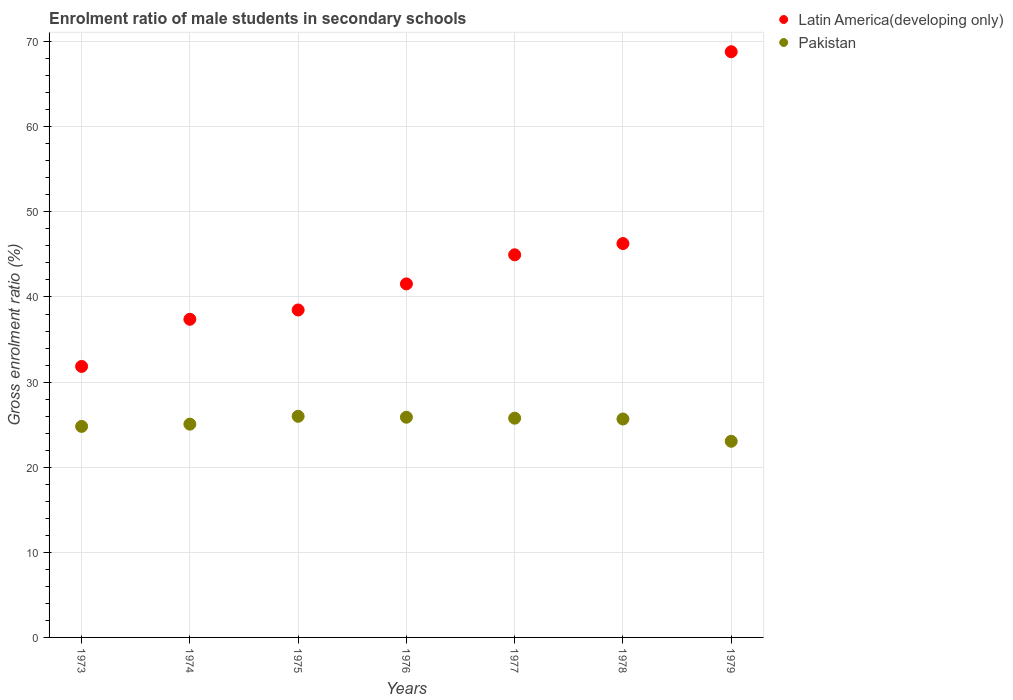How many different coloured dotlines are there?
Provide a succinct answer. 2. What is the enrolment ratio of male students in secondary schools in Pakistan in 1979?
Give a very brief answer. 23.05. Across all years, what is the maximum enrolment ratio of male students in secondary schools in Pakistan?
Provide a short and direct response. 25.98. Across all years, what is the minimum enrolment ratio of male students in secondary schools in Pakistan?
Offer a terse response. 23.05. In which year was the enrolment ratio of male students in secondary schools in Pakistan maximum?
Make the answer very short. 1975. In which year was the enrolment ratio of male students in secondary schools in Pakistan minimum?
Offer a very short reply. 1979. What is the total enrolment ratio of male students in secondary schools in Pakistan in the graph?
Give a very brief answer. 176.18. What is the difference between the enrolment ratio of male students in secondary schools in Pakistan in 1973 and that in 1977?
Provide a short and direct response. -0.97. What is the difference between the enrolment ratio of male students in secondary schools in Latin America(developing only) in 1973 and the enrolment ratio of male students in secondary schools in Pakistan in 1974?
Your response must be concise. 6.78. What is the average enrolment ratio of male students in secondary schools in Pakistan per year?
Offer a very short reply. 25.17. In the year 1974, what is the difference between the enrolment ratio of male students in secondary schools in Latin America(developing only) and enrolment ratio of male students in secondary schools in Pakistan?
Your response must be concise. 12.32. In how many years, is the enrolment ratio of male students in secondary schools in Latin America(developing only) greater than 22 %?
Give a very brief answer. 7. What is the ratio of the enrolment ratio of male students in secondary schools in Pakistan in 1975 to that in 1978?
Offer a very short reply. 1.01. Is the enrolment ratio of male students in secondary schools in Pakistan in 1977 less than that in 1979?
Offer a terse response. No. What is the difference between the highest and the second highest enrolment ratio of male students in secondary schools in Pakistan?
Your response must be concise. 0.11. What is the difference between the highest and the lowest enrolment ratio of male students in secondary schools in Pakistan?
Ensure brevity in your answer.  2.93. In how many years, is the enrolment ratio of male students in secondary schools in Latin America(developing only) greater than the average enrolment ratio of male students in secondary schools in Latin America(developing only) taken over all years?
Offer a very short reply. 3. Is the sum of the enrolment ratio of male students in secondary schools in Latin America(developing only) in 1978 and 1979 greater than the maximum enrolment ratio of male students in secondary schools in Pakistan across all years?
Offer a terse response. Yes. Does the enrolment ratio of male students in secondary schools in Latin America(developing only) monotonically increase over the years?
Provide a succinct answer. Yes. Is the enrolment ratio of male students in secondary schools in Latin America(developing only) strictly less than the enrolment ratio of male students in secondary schools in Pakistan over the years?
Make the answer very short. No. How many years are there in the graph?
Provide a succinct answer. 7. What is the difference between two consecutive major ticks on the Y-axis?
Keep it short and to the point. 10. Are the values on the major ticks of Y-axis written in scientific E-notation?
Offer a very short reply. No. Does the graph contain grids?
Provide a short and direct response. Yes. How many legend labels are there?
Offer a very short reply. 2. What is the title of the graph?
Make the answer very short. Enrolment ratio of male students in secondary schools. Does "Papua New Guinea" appear as one of the legend labels in the graph?
Provide a short and direct response. No. What is the label or title of the Y-axis?
Provide a short and direct response. Gross enrolment ratio (%). What is the Gross enrolment ratio (%) in Latin America(developing only) in 1973?
Provide a succinct answer. 31.84. What is the Gross enrolment ratio (%) in Pakistan in 1973?
Ensure brevity in your answer.  24.79. What is the Gross enrolment ratio (%) of Latin America(developing only) in 1974?
Offer a terse response. 37.38. What is the Gross enrolment ratio (%) of Pakistan in 1974?
Keep it short and to the point. 25.06. What is the Gross enrolment ratio (%) in Latin America(developing only) in 1975?
Your answer should be compact. 38.48. What is the Gross enrolment ratio (%) of Pakistan in 1975?
Ensure brevity in your answer.  25.98. What is the Gross enrolment ratio (%) of Latin America(developing only) in 1976?
Make the answer very short. 41.54. What is the Gross enrolment ratio (%) in Pakistan in 1976?
Your answer should be very brief. 25.87. What is the Gross enrolment ratio (%) of Latin America(developing only) in 1977?
Make the answer very short. 44.96. What is the Gross enrolment ratio (%) in Pakistan in 1977?
Offer a very short reply. 25.76. What is the Gross enrolment ratio (%) of Latin America(developing only) in 1978?
Your answer should be compact. 46.28. What is the Gross enrolment ratio (%) of Pakistan in 1978?
Your answer should be very brief. 25.66. What is the Gross enrolment ratio (%) in Latin America(developing only) in 1979?
Give a very brief answer. 68.82. What is the Gross enrolment ratio (%) in Pakistan in 1979?
Make the answer very short. 23.05. Across all years, what is the maximum Gross enrolment ratio (%) in Latin America(developing only)?
Your answer should be very brief. 68.82. Across all years, what is the maximum Gross enrolment ratio (%) in Pakistan?
Keep it short and to the point. 25.98. Across all years, what is the minimum Gross enrolment ratio (%) of Latin America(developing only)?
Offer a very short reply. 31.84. Across all years, what is the minimum Gross enrolment ratio (%) of Pakistan?
Make the answer very short. 23.05. What is the total Gross enrolment ratio (%) in Latin America(developing only) in the graph?
Provide a succinct answer. 309.3. What is the total Gross enrolment ratio (%) of Pakistan in the graph?
Give a very brief answer. 176.18. What is the difference between the Gross enrolment ratio (%) of Latin America(developing only) in 1973 and that in 1974?
Provide a short and direct response. -5.54. What is the difference between the Gross enrolment ratio (%) of Pakistan in 1973 and that in 1974?
Provide a short and direct response. -0.27. What is the difference between the Gross enrolment ratio (%) in Latin America(developing only) in 1973 and that in 1975?
Provide a short and direct response. -6.63. What is the difference between the Gross enrolment ratio (%) of Pakistan in 1973 and that in 1975?
Make the answer very short. -1.19. What is the difference between the Gross enrolment ratio (%) in Latin America(developing only) in 1973 and that in 1976?
Make the answer very short. -9.7. What is the difference between the Gross enrolment ratio (%) in Pakistan in 1973 and that in 1976?
Offer a very short reply. -1.08. What is the difference between the Gross enrolment ratio (%) of Latin America(developing only) in 1973 and that in 1977?
Your answer should be very brief. -13.12. What is the difference between the Gross enrolment ratio (%) in Pakistan in 1973 and that in 1977?
Make the answer very short. -0.97. What is the difference between the Gross enrolment ratio (%) in Latin America(developing only) in 1973 and that in 1978?
Ensure brevity in your answer.  -14.44. What is the difference between the Gross enrolment ratio (%) in Pakistan in 1973 and that in 1978?
Give a very brief answer. -0.87. What is the difference between the Gross enrolment ratio (%) in Latin America(developing only) in 1973 and that in 1979?
Make the answer very short. -36.98. What is the difference between the Gross enrolment ratio (%) in Pakistan in 1973 and that in 1979?
Provide a succinct answer. 1.75. What is the difference between the Gross enrolment ratio (%) of Latin America(developing only) in 1974 and that in 1975?
Offer a very short reply. -1.09. What is the difference between the Gross enrolment ratio (%) of Pakistan in 1974 and that in 1975?
Give a very brief answer. -0.92. What is the difference between the Gross enrolment ratio (%) of Latin America(developing only) in 1974 and that in 1976?
Make the answer very short. -4.16. What is the difference between the Gross enrolment ratio (%) in Pakistan in 1974 and that in 1976?
Your answer should be compact. -0.81. What is the difference between the Gross enrolment ratio (%) of Latin America(developing only) in 1974 and that in 1977?
Keep it short and to the point. -7.58. What is the difference between the Gross enrolment ratio (%) in Pakistan in 1974 and that in 1977?
Your answer should be very brief. -0.7. What is the difference between the Gross enrolment ratio (%) in Latin America(developing only) in 1974 and that in 1978?
Provide a short and direct response. -8.9. What is the difference between the Gross enrolment ratio (%) in Pakistan in 1974 and that in 1978?
Ensure brevity in your answer.  -0.6. What is the difference between the Gross enrolment ratio (%) in Latin America(developing only) in 1974 and that in 1979?
Your answer should be very brief. -31.44. What is the difference between the Gross enrolment ratio (%) in Pakistan in 1974 and that in 1979?
Your answer should be very brief. 2.01. What is the difference between the Gross enrolment ratio (%) in Latin America(developing only) in 1975 and that in 1976?
Provide a short and direct response. -3.06. What is the difference between the Gross enrolment ratio (%) of Pakistan in 1975 and that in 1976?
Offer a very short reply. 0.11. What is the difference between the Gross enrolment ratio (%) in Latin America(developing only) in 1975 and that in 1977?
Provide a short and direct response. -6.48. What is the difference between the Gross enrolment ratio (%) in Pakistan in 1975 and that in 1977?
Your response must be concise. 0.22. What is the difference between the Gross enrolment ratio (%) in Latin America(developing only) in 1975 and that in 1978?
Provide a short and direct response. -7.8. What is the difference between the Gross enrolment ratio (%) in Pakistan in 1975 and that in 1978?
Your answer should be very brief. 0.32. What is the difference between the Gross enrolment ratio (%) in Latin America(developing only) in 1975 and that in 1979?
Offer a terse response. -30.34. What is the difference between the Gross enrolment ratio (%) in Pakistan in 1975 and that in 1979?
Offer a terse response. 2.93. What is the difference between the Gross enrolment ratio (%) in Latin America(developing only) in 1976 and that in 1977?
Offer a terse response. -3.42. What is the difference between the Gross enrolment ratio (%) in Pakistan in 1976 and that in 1977?
Give a very brief answer. 0.11. What is the difference between the Gross enrolment ratio (%) of Latin America(developing only) in 1976 and that in 1978?
Provide a short and direct response. -4.74. What is the difference between the Gross enrolment ratio (%) of Pakistan in 1976 and that in 1978?
Your answer should be compact. 0.21. What is the difference between the Gross enrolment ratio (%) in Latin America(developing only) in 1976 and that in 1979?
Keep it short and to the point. -27.28. What is the difference between the Gross enrolment ratio (%) of Pakistan in 1976 and that in 1979?
Offer a terse response. 2.83. What is the difference between the Gross enrolment ratio (%) of Latin America(developing only) in 1977 and that in 1978?
Provide a short and direct response. -1.32. What is the difference between the Gross enrolment ratio (%) of Pakistan in 1977 and that in 1978?
Provide a short and direct response. 0.1. What is the difference between the Gross enrolment ratio (%) of Latin America(developing only) in 1977 and that in 1979?
Ensure brevity in your answer.  -23.86. What is the difference between the Gross enrolment ratio (%) in Pakistan in 1977 and that in 1979?
Your answer should be compact. 2.71. What is the difference between the Gross enrolment ratio (%) of Latin America(developing only) in 1978 and that in 1979?
Ensure brevity in your answer.  -22.54. What is the difference between the Gross enrolment ratio (%) in Pakistan in 1978 and that in 1979?
Give a very brief answer. 2.62. What is the difference between the Gross enrolment ratio (%) of Latin America(developing only) in 1973 and the Gross enrolment ratio (%) of Pakistan in 1974?
Offer a very short reply. 6.78. What is the difference between the Gross enrolment ratio (%) of Latin America(developing only) in 1973 and the Gross enrolment ratio (%) of Pakistan in 1975?
Give a very brief answer. 5.86. What is the difference between the Gross enrolment ratio (%) in Latin America(developing only) in 1973 and the Gross enrolment ratio (%) in Pakistan in 1976?
Give a very brief answer. 5.97. What is the difference between the Gross enrolment ratio (%) in Latin America(developing only) in 1973 and the Gross enrolment ratio (%) in Pakistan in 1977?
Your response must be concise. 6.08. What is the difference between the Gross enrolment ratio (%) in Latin America(developing only) in 1973 and the Gross enrolment ratio (%) in Pakistan in 1978?
Your answer should be very brief. 6.18. What is the difference between the Gross enrolment ratio (%) of Latin America(developing only) in 1973 and the Gross enrolment ratio (%) of Pakistan in 1979?
Keep it short and to the point. 8.8. What is the difference between the Gross enrolment ratio (%) in Latin America(developing only) in 1974 and the Gross enrolment ratio (%) in Pakistan in 1975?
Your answer should be compact. 11.4. What is the difference between the Gross enrolment ratio (%) of Latin America(developing only) in 1974 and the Gross enrolment ratio (%) of Pakistan in 1976?
Offer a terse response. 11.51. What is the difference between the Gross enrolment ratio (%) of Latin America(developing only) in 1974 and the Gross enrolment ratio (%) of Pakistan in 1977?
Provide a short and direct response. 11.62. What is the difference between the Gross enrolment ratio (%) in Latin America(developing only) in 1974 and the Gross enrolment ratio (%) in Pakistan in 1978?
Your answer should be compact. 11.72. What is the difference between the Gross enrolment ratio (%) in Latin America(developing only) in 1974 and the Gross enrolment ratio (%) in Pakistan in 1979?
Your answer should be compact. 14.34. What is the difference between the Gross enrolment ratio (%) in Latin America(developing only) in 1975 and the Gross enrolment ratio (%) in Pakistan in 1976?
Provide a short and direct response. 12.6. What is the difference between the Gross enrolment ratio (%) of Latin America(developing only) in 1975 and the Gross enrolment ratio (%) of Pakistan in 1977?
Provide a short and direct response. 12.71. What is the difference between the Gross enrolment ratio (%) of Latin America(developing only) in 1975 and the Gross enrolment ratio (%) of Pakistan in 1978?
Offer a very short reply. 12.81. What is the difference between the Gross enrolment ratio (%) of Latin America(developing only) in 1975 and the Gross enrolment ratio (%) of Pakistan in 1979?
Provide a short and direct response. 15.43. What is the difference between the Gross enrolment ratio (%) in Latin America(developing only) in 1976 and the Gross enrolment ratio (%) in Pakistan in 1977?
Ensure brevity in your answer.  15.78. What is the difference between the Gross enrolment ratio (%) in Latin America(developing only) in 1976 and the Gross enrolment ratio (%) in Pakistan in 1978?
Provide a short and direct response. 15.87. What is the difference between the Gross enrolment ratio (%) in Latin America(developing only) in 1976 and the Gross enrolment ratio (%) in Pakistan in 1979?
Ensure brevity in your answer.  18.49. What is the difference between the Gross enrolment ratio (%) in Latin America(developing only) in 1977 and the Gross enrolment ratio (%) in Pakistan in 1978?
Your response must be concise. 19.29. What is the difference between the Gross enrolment ratio (%) of Latin America(developing only) in 1977 and the Gross enrolment ratio (%) of Pakistan in 1979?
Give a very brief answer. 21.91. What is the difference between the Gross enrolment ratio (%) in Latin America(developing only) in 1978 and the Gross enrolment ratio (%) in Pakistan in 1979?
Offer a terse response. 23.23. What is the average Gross enrolment ratio (%) in Latin America(developing only) per year?
Make the answer very short. 44.19. What is the average Gross enrolment ratio (%) of Pakistan per year?
Make the answer very short. 25.17. In the year 1973, what is the difference between the Gross enrolment ratio (%) of Latin America(developing only) and Gross enrolment ratio (%) of Pakistan?
Keep it short and to the point. 7.05. In the year 1974, what is the difference between the Gross enrolment ratio (%) of Latin America(developing only) and Gross enrolment ratio (%) of Pakistan?
Provide a succinct answer. 12.32. In the year 1975, what is the difference between the Gross enrolment ratio (%) in Latin America(developing only) and Gross enrolment ratio (%) in Pakistan?
Offer a very short reply. 12.49. In the year 1976, what is the difference between the Gross enrolment ratio (%) of Latin America(developing only) and Gross enrolment ratio (%) of Pakistan?
Make the answer very short. 15.67. In the year 1977, what is the difference between the Gross enrolment ratio (%) in Latin America(developing only) and Gross enrolment ratio (%) in Pakistan?
Make the answer very short. 19.2. In the year 1978, what is the difference between the Gross enrolment ratio (%) in Latin America(developing only) and Gross enrolment ratio (%) in Pakistan?
Ensure brevity in your answer.  20.62. In the year 1979, what is the difference between the Gross enrolment ratio (%) in Latin America(developing only) and Gross enrolment ratio (%) in Pakistan?
Give a very brief answer. 45.77. What is the ratio of the Gross enrolment ratio (%) of Latin America(developing only) in 1973 to that in 1974?
Offer a terse response. 0.85. What is the ratio of the Gross enrolment ratio (%) in Pakistan in 1973 to that in 1974?
Your response must be concise. 0.99. What is the ratio of the Gross enrolment ratio (%) in Latin America(developing only) in 1973 to that in 1975?
Your answer should be very brief. 0.83. What is the ratio of the Gross enrolment ratio (%) of Pakistan in 1973 to that in 1975?
Keep it short and to the point. 0.95. What is the ratio of the Gross enrolment ratio (%) in Latin America(developing only) in 1973 to that in 1976?
Keep it short and to the point. 0.77. What is the ratio of the Gross enrolment ratio (%) of Latin America(developing only) in 1973 to that in 1977?
Ensure brevity in your answer.  0.71. What is the ratio of the Gross enrolment ratio (%) of Pakistan in 1973 to that in 1977?
Give a very brief answer. 0.96. What is the ratio of the Gross enrolment ratio (%) of Latin America(developing only) in 1973 to that in 1978?
Your answer should be very brief. 0.69. What is the ratio of the Gross enrolment ratio (%) in Pakistan in 1973 to that in 1978?
Give a very brief answer. 0.97. What is the ratio of the Gross enrolment ratio (%) of Latin America(developing only) in 1973 to that in 1979?
Offer a terse response. 0.46. What is the ratio of the Gross enrolment ratio (%) in Pakistan in 1973 to that in 1979?
Your answer should be compact. 1.08. What is the ratio of the Gross enrolment ratio (%) in Latin America(developing only) in 1974 to that in 1975?
Provide a short and direct response. 0.97. What is the ratio of the Gross enrolment ratio (%) in Pakistan in 1974 to that in 1975?
Offer a terse response. 0.96. What is the ratio of the Gross enrolment ratio (%) of Latin America(developing only) in 1974 to that in 1976?
Ensure brevity in your answer.  0.9. What is the ratio of the Gross enrolment ratio (%) of Pakistan in 1974 to that in 1976?
Give a very brief answer. 0.97. What is the ratio of the Gross enrolment ratio (%) in Latin America(developing only) in 1974 to that in 1977?
Give a very brief answer. 0.83. What is the ratio of the Gross enrolment ratio (%) of Pakistan in 1974 to that in 1977?
Offer a terse response. 0.97. What is the ratio of the Gross enrolment ratio (%) in Latin America(developing only) in 1974 to that in 1978?
Make the answer very short. 0.81. What is the ratio of the Gross enrolment ratio (%) of Pakistan in 1974 to that in 1978?
Provide a short and direct response. 0.98. What is the ratio of the Gross enrolment ratio (%) of Latin America(developing only) in 1974 to that in 1979?
Give a very brief answer. 0.54. What is the ratio of the Gross enrolment ratio (%) in Pakistan in 1974 to that in 1979?
Offer a terse response. 1.09. What is the ratio of the Gross enrolment ratio (%) in Latin America(developing only) in 1975 to that in 1976?
Your answer should be very brief. 0.93. What is the ratio of the Gross enrolment ratio (%) of Latin America(developing only) in 1975 to that in 1977?
Ensure brevity in your answer.  0.86. What is the ratio of the Gross enrolment ratio (%) in Pakistan in 1975 to that in 1977?
Keep it short and to the point. 1.01. What is the ratio of the Gross enrolment ratio (%) in Latin America(developing only) in 1975 to that in 1978?
Your answer should be very brief. 0.83. What is the ratio of the Gross enrolment ratio (%) in Pakistan in 1975 to that in 1978?
Your answer should be very brief. 1.01. What is the ratio of the Gross enrolment ratio (%) of Latin America(developing only) in 1975 to that in 1979?
Offer a very short reply. 0.56. What is the ratio of the Gross enrolment ratio (%) of Pakistan in 1975 to that in 1979?
Keep it short and to the point. 1.13. What is the ratio of the Gross enrolment ratio (%) of Latin America(developing only) in 1976 to that in 1977?
Your response must be concise. 0.92. What is the ratio of the Gross enrolment ratio (%) in Pakistan in 1976 to that in 1977?
Offer a very short reply. 1. What is the ratio of the Gross enrolment ratio (%) of Latin America(developing only) in 1976 to that in 1978?
Give a very brief answer. 0.9. What is the ratio of the Gross enrolment ratio (%) of Pakistan in 1976 to that in 1978?
Your answer should be compact. 1.01. What is the ratio of the Gross enrolment ratio (%) in Latin America(developing only) in 1976 to that in 1979?
Ensure brevity in your answer.  0.6. What is the ratio of the Gross enrolment ratio (%) of Pakistan in 1976 to that in 1979?
Your answer should be very brief. 1.12. What is the ratio of the Gross enrolment ratio (%) in Latin America(developing only) in 1977 to that in 1978?
Ensure brevity in your answer.  0.97. What is the ratio of the Gross enrolment ratio (%) of Latin America(developing only) in 1977 to that in 1979?
Keep it short and to the point. 0.65. What is the ratio of the Gross enrolment ratio (%) of Pakistan in 1977 to that in 1979?
Your answer should be compact. 1.12. What is the ratio of the Gross enrolment ratio (%) in Latin America(developing only) in 1978 to that in 1979?
Keep it short and to the point. 0.67. What is the ratio of the Gross enrolment ratio (%) in Pakistan in 1978 to that in 1979?
Keep it short and to the point. 1.11. What is the difference between the highest and the second highest Gross enrolment ratio (%) in Latin America(developing only)?
Provide a short and direct response. 22.54. What is the difference between the highest and the second highest Gross enrolment ratio (%) in Pakistan?
Keep it short and to the point. 0.11. What is the difference between the highest and the lowest Gross enrolment ratio (%) in Latin America(developing only)?
Provide a short and direct response. 36.98. What is the difference between the highest and the lowest Gross enrolment ratio (%) in Pakistan?
Provide a succinct answer. 2.93. 